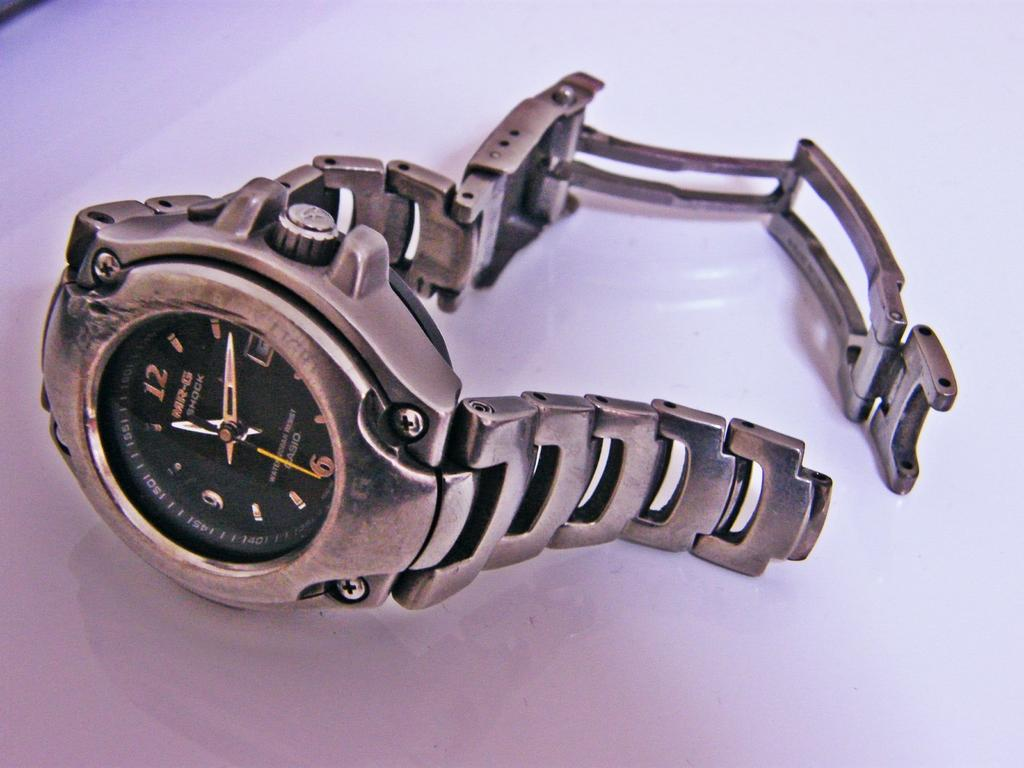What can be seen in the image? There is a watch in the image. What is the watch placed on? The watch is on a white object. What type of curve can be seen on the watch in the image? There is no curve mentioned or visible on the watch in the image. 